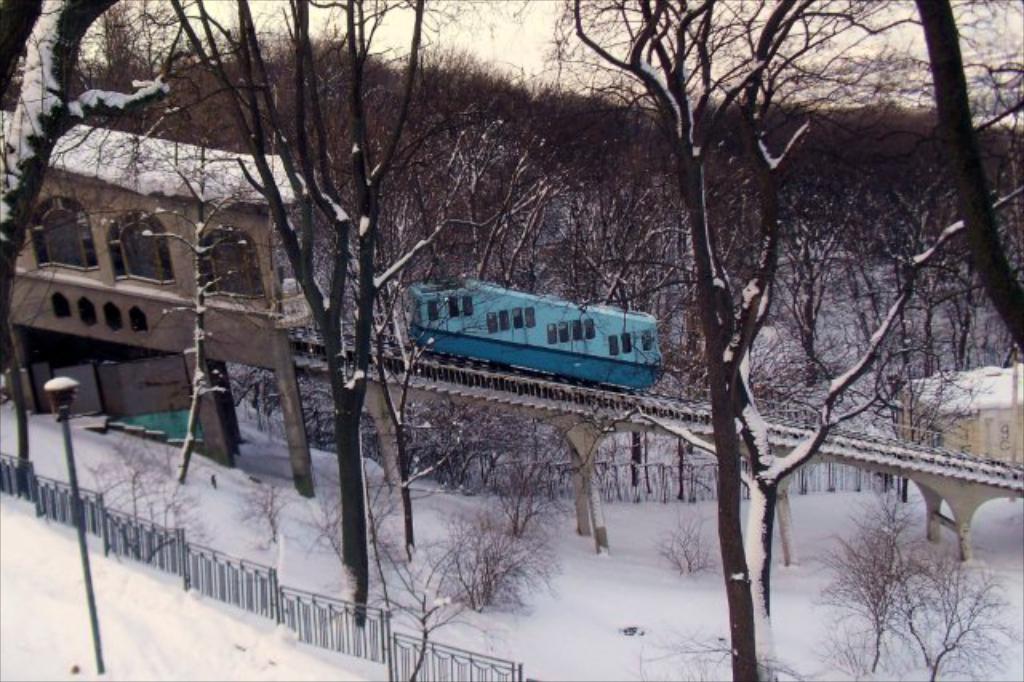Describe this image in one or two sentences. In this image I can see a train. Here I can see a house. Here I can see a fence, snow and street light. In the background I can see trees and the sky. 